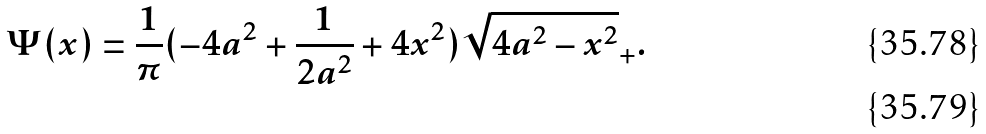<formula> <loc_0><loc_0><loc_500><loc_500>\Psi ( x ) & = \frac { 1 } { \pi } ( - 4 a ^ { 2 } + \frac { 1 } { 2 a ^ { 2 } } + 4 x ^ { 2 } ) \sqrt { 4 a ^ { 2 } - x ^ { 2 } } _ { + } . \\</formula> 